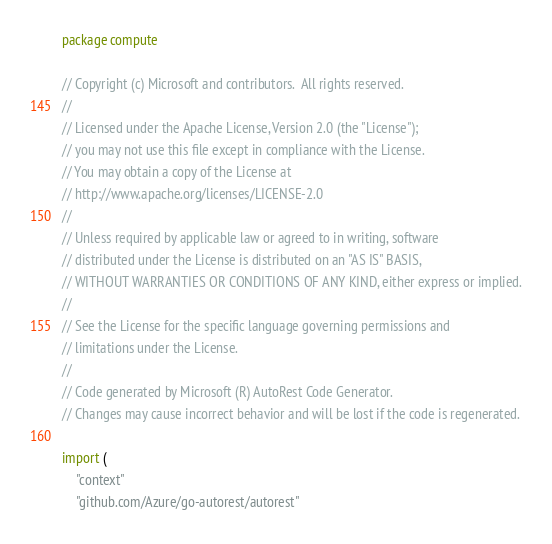Convert code to text. <code><loc_0><loc_0><loc_500><loc_500><_Go_>package compute

// Copyright (c) Microsoft and contributors.  All rights reserved.
//
// Licensed under the Apache License, Version 2.0 (the "License");
// you may not use this file except in compliance with the License.
// You may obtain a copy of the License at
// http://www.apache.org/licenses/LICENSE-2.0
//
// Unless required by applicable law or agreed to in writing, software
// distributed under the License is distributed on an "AS IS" BASIS,
// WITHOUT WARRANTIES OR CONDITIONS OF ANY KIND, either express or implied.
//
// See the License for the specific language governing permissions and
// limitations under the License.
//
// Code generated by Microsoft (R) AutoRest Code Generator.
// Changes may cause incorrect behavior and will be lost if the code is regenerated.

import (
	"context"
	"github.com/Azure/go-autorest/autorest"</code> 